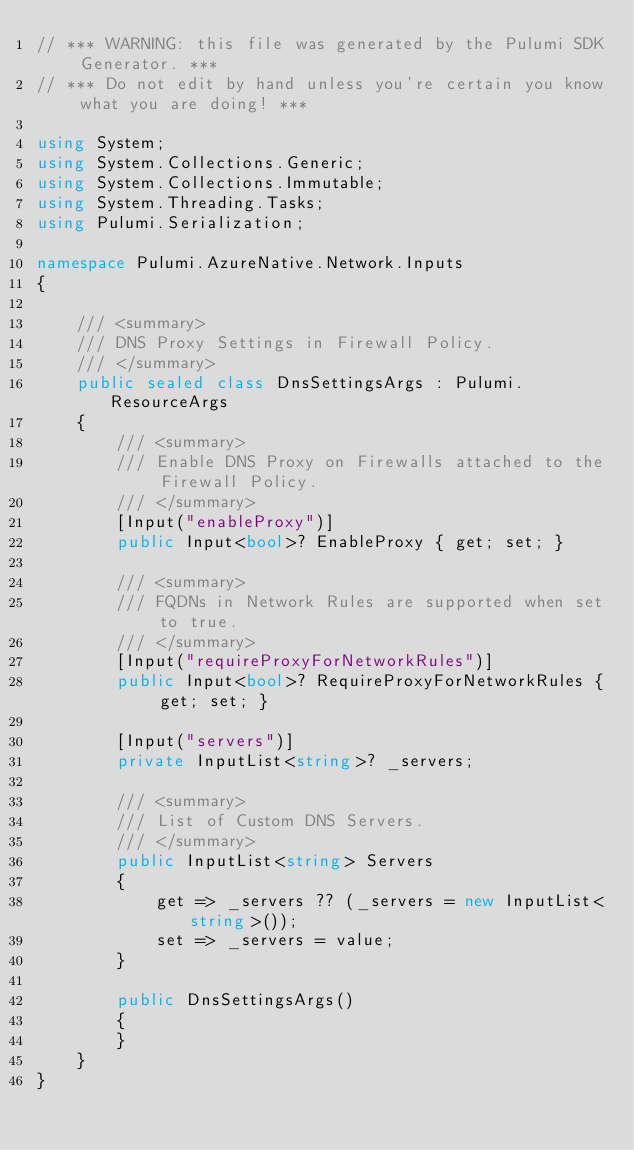<code> <loc_0><loc_0><loc_500><loc_500><_C#_>// *** WARNING: this file was generated by the Pulumi SDK Generator. ***
// *** Do not edit by hand unless you're certain you know what you are doing! ***

using System;
using System.Collections.Generic;
using System.Collections.Immutable;
using System.Threading.Tasks;
using Pulumi.Serialization;

namespace Pulumi.AzureNative.Network.Inputs
{

    /// <summary>
    /// DNS Proxy Settings in Firewall Policy.
    /// </summary>
    public sealed class DnsSettingsArgs : Pulumi.ResourceArgs
    {
        /// <summary>
        /// Enable DNS Proxy on Firewalls attached to the Firewall Policy.
        /// </summary>
        [Input("enableProxy")]
        public Input<bool>? EnableProxy { get; set; }

        /// <summary>
        /// FQDNs in Network Rules are supported when set to true.
        /// </summary>
        [Input("requireProxyForNetworkRules")]
        public Input<bool>? RequireProxyForNetworkRules { get; set; }

        [Input("servers")]
        private InputList<string>? _servers;

        /// <summary>
        /// List of Custom DNS Servers.
        /// </summary>
        public InputList<string> Servers
        {
            get => _servers ?? (_servers = new InputList<string>());
            set => _servers = value;
        }

        public DnsSettingsArgs()
        {
        }
    }
}
</code> 